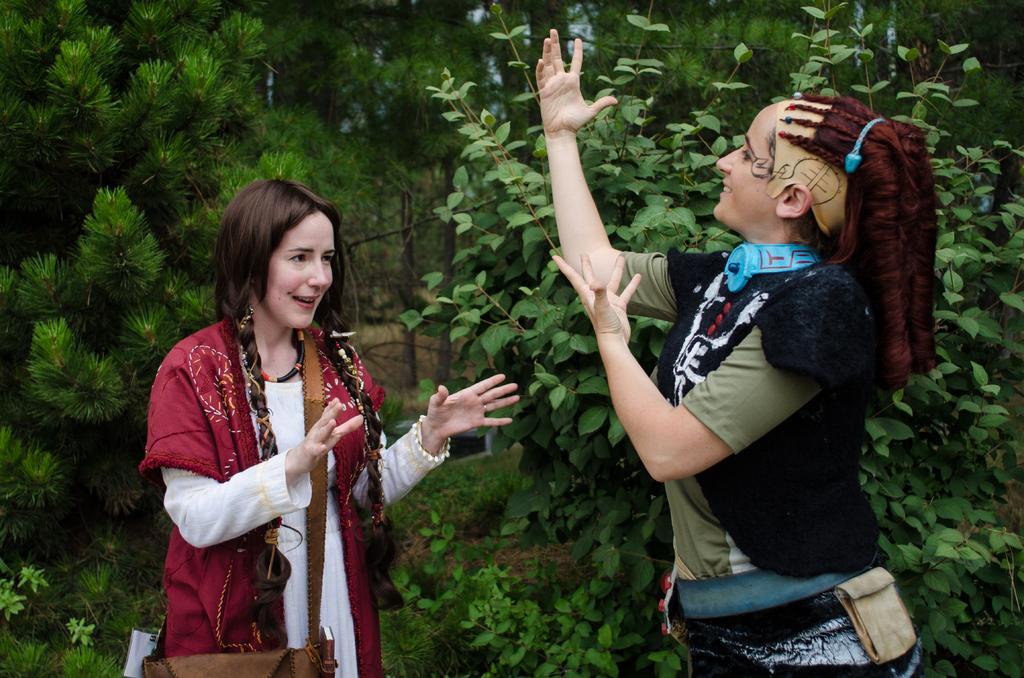In one or two sentences, can you explain what this image depicts? In this image, we can see people and are wearing bags. In the background, there are trees and we can see poles. 